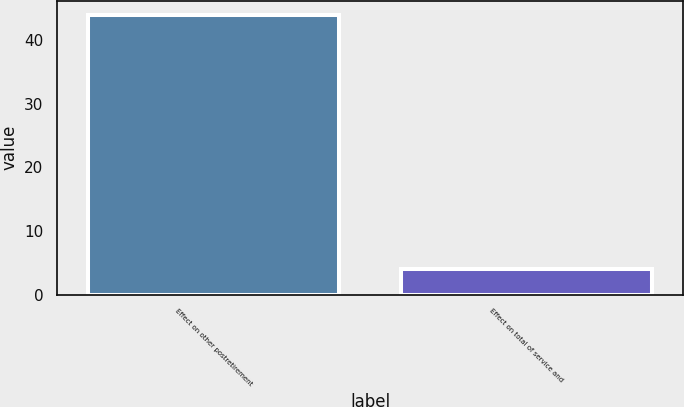Convert chart to OTSL. <chart><loc_0><loc_0><loc_500><loc_500><bar_chart><fcel>Effect on other postretirement<fcel>Effect on total of service and<nl><fcel>44<fcel>4<nl></chart> 